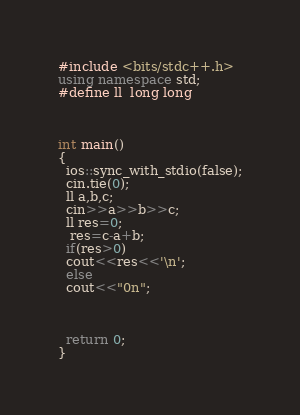Convert code to text. <code><loc_0><loc_0><loc_500><loc_500><_C++_>#include <bits/stdc++.h>
using namespace std;
#define ll  long long



int main()
{
  ios::sync_with_stdio(false);
  cin.tie(0);
  ll a,b,c;
  cin>>a>>b>>c;
  ll res=0;
   res=c-a+b;
  if(res>0)
  cout<<res<<'\n';
  else
  cout<<"0n";



  return 0;
}
</code> 